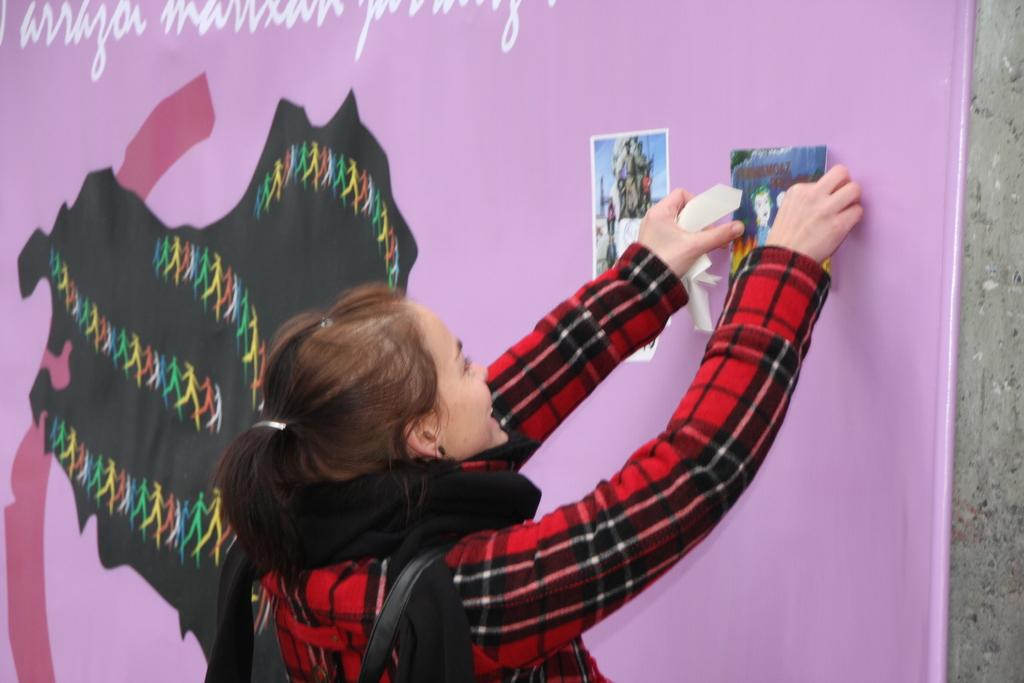Who is the main subject in the image? There is a lady in the image. What is the lady doing in the image? The lady is pasting a poster a poster on the wall. What can be seen in the background of the image? There is a board and a wall in the background of the image. How much dirt is visible on the lady's hands while pasting the poster? There is no dirt visible on the lady's hands in the image. What type of error is the lady making while pasting the poster? There is no error visible in the image; the lady is simply pasting a poster on the wall. 